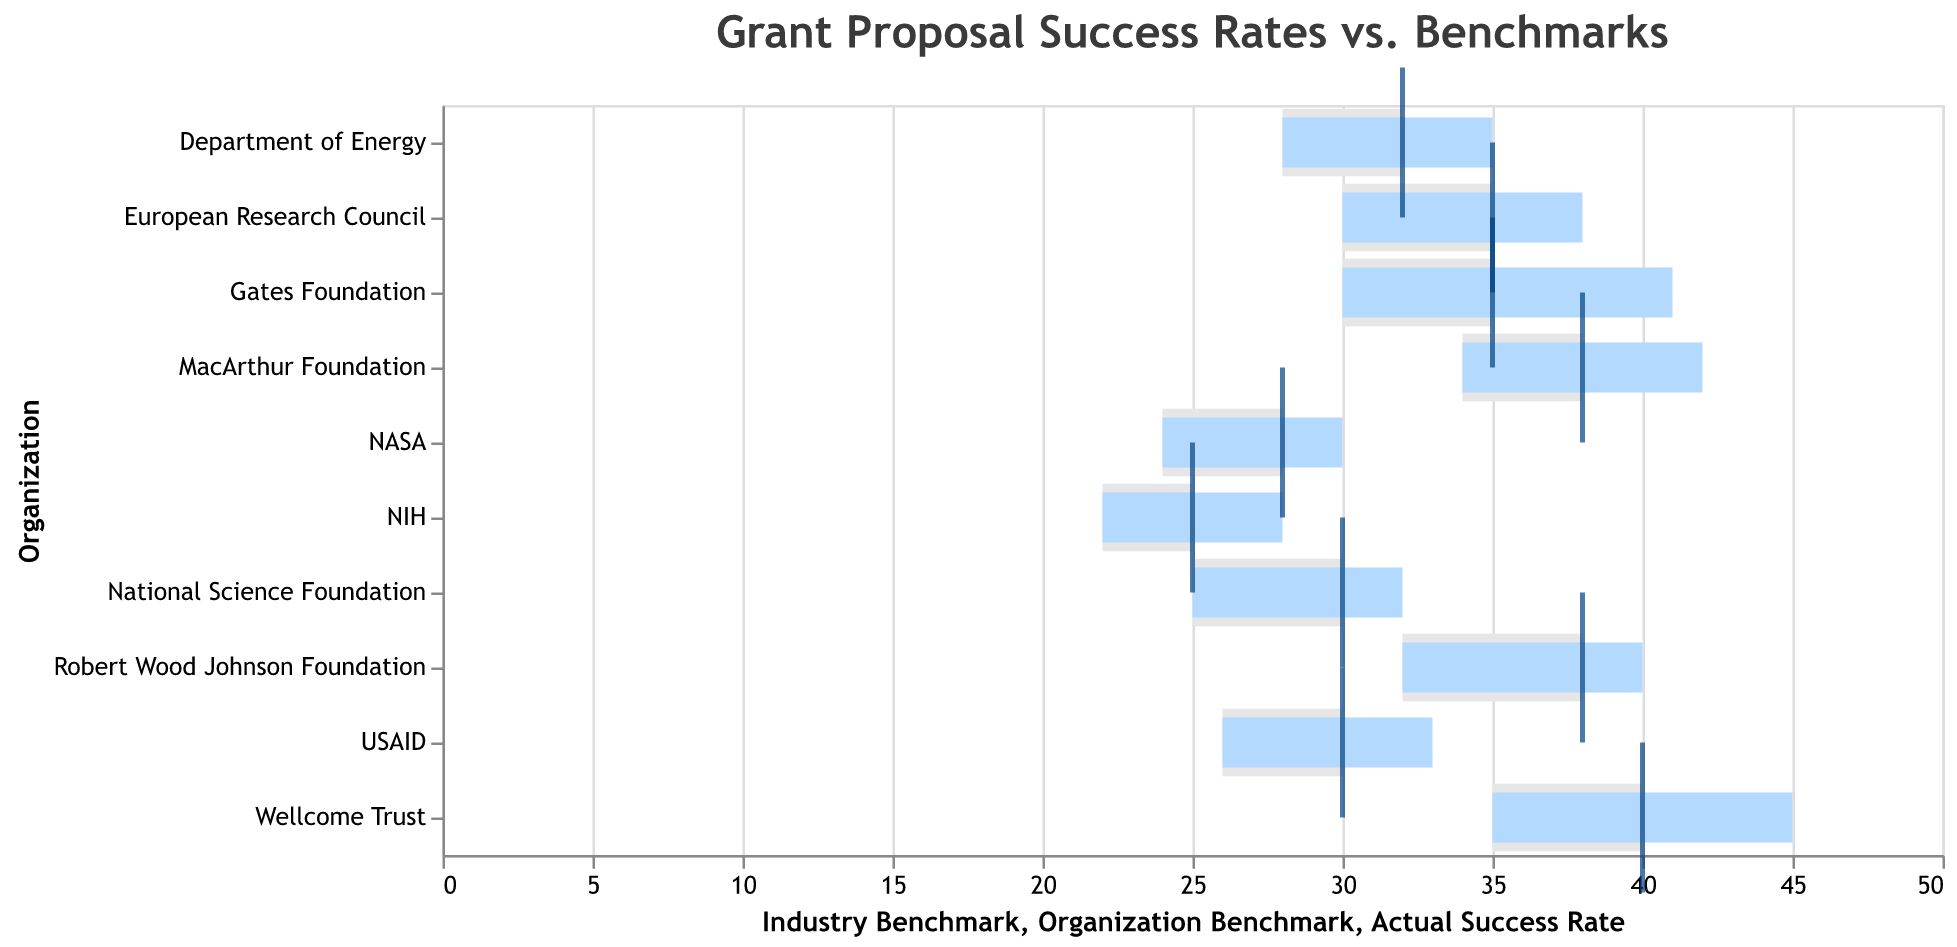what is the title of the chart? Look at the top of the figure where the title is displayed.
Answer: Grant Proposal Success Rates vs. Benchmarks Which organization has the highest actual success rate? Scan the lengths of the bars representing the actual success rates and find the longest bar.
Answer: Wellcome Trust What is the difference between the actual success rate and industry benchmark for MacArthur Foundation? Subtract the industry benchmark value for MacArthur Foundation from its actual success rate (42 - 34).
Answer: 8 Which organization's actual success rate exceeds its own benchmark by the largest margin? Calculate the difference between the actual success rate and the organization benchmark for all organizations and identify the maximum value. The calculation for Wellcome Trust is (45-40)=5, for Gates Foundation is (41-35)=6, and so on.
Answer: Gates Foundation Does any organization have an actual success rate lower than its industry benchmark? Compare the actual success rates with their corresponding industry benchmarks for all organizations.
Answer: No What is the median actual success rate among the organizations shown? Order the actual success rates from lowest to highest and find the middle value or the average of the two middle values if there’s an even number of data points. The ordered list is 28, 30, 32, 33, 35, 38, 40, 41, 42, 45. The middle values are 35 and 38, so the median is (35+38)/2.
Answer: 36.5 For which funding source do the organization benchmark and industry benchmark differ by the least margin? Compute the difference between the organization benchmark and industry benchmark for each organization and identify the minimum value. For NSF, it's 30-25=5, for NIH it's 25-22=3, etc.
Answer: NIH How many organizations have an actual success rate of 40% or higher? Count the number of organizations with actual success rates 40 or higher. (Gates Foundation, Wellcome Trust, Robert Wood Johnson Foundation, MacArthur Foundation).
Answer: 4 What are the colors used to represent the actual success rate bars? Identify the color of the bars representing the actual success rate.
Answer: Light blue 